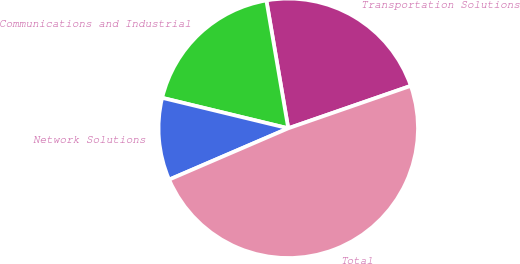Convert chart. <chart><loc_0><loc_0><loc_500><loc_500><pie_chart><fcel>Transportation Solutions<fcel>Communications and Industrial<fcel>Network Solutions<fcel>Total<nl><fcel>22.39%<fcel>18.53%<fcel>10.25%<fcel>48.84%<nl></chart> 